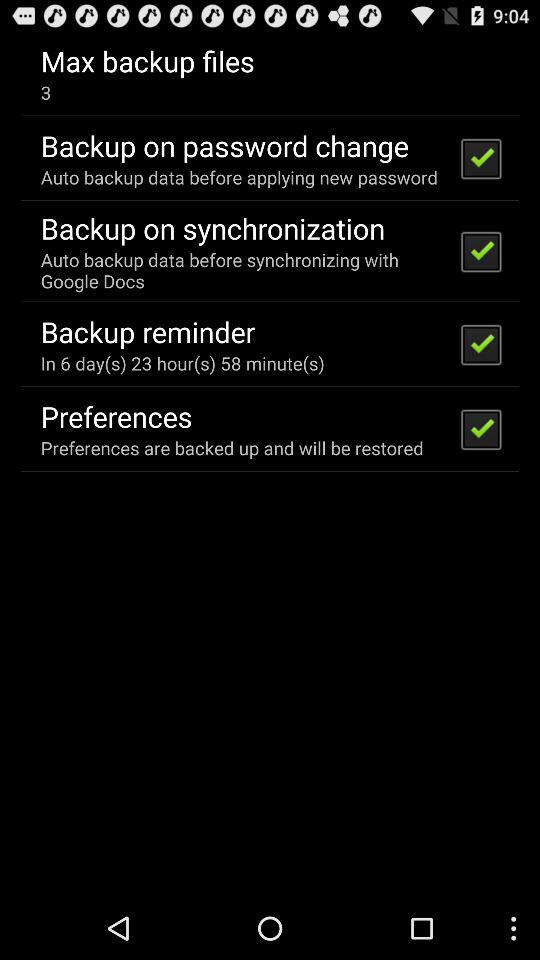How long will it take to remind for the backup? It will take 6 days 23 hours 58 minutes to remind for the backup. 